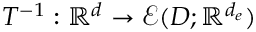<formula> <loc_0><loc_0><loc_500><loc_500>T ^ { - 1 } \colon \mathbb { R } ^ { d } \rightarrow \mathcal { E } ( D ; \mathbb { R } ^ { d _ { e } } )</formula> 